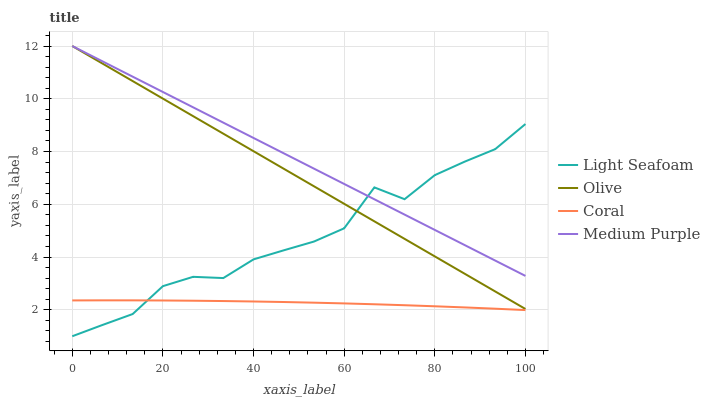Does Coral have the minimum area under the curve?
Answer yes or no. Yes. Does Medium Purple have the maximum area under the curve?
Answer yes or no. Yes. Does Medium Purple have the minimum area under the curve?
Answer yes or no. No. Does Coral have the maximum area under the curve?
Answer yes or no. No. Is Olive the smoothest?
Answer yes or no. Yes. Is Light Seafoam the roughest?
Answer yes or no. Yes. Is Medium Purple the smoothest?
Answer yes or no. No. Is Medium Purple the roughest?
Answer yes or no. No. Does Light Seafoam have the lowest value?
Answer yes or no. Yes. Does Coral have the lowest value?
Answer yes or no. No. Does Medium Purple have the highest value?
Answer yes or no. Yes. Does Coral have the highest value?
Answer yes or no. No. Is Coral less than Medium Purple?
Answer yes or no. Yes. Is Olive greater than Coral?
Answer yes or no. Yes. Does Medium Purple intersect Olive?
Answer yes or no. Yes. Is Medium Purple less than Olive?
Answer yes or no. No. Is Medium Purple greater than Olive?
Answer yes or no. No. Does Coral intersect Medium Purple?
Answer yes or no. No. 